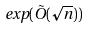Convert formula to latex. <formula><loc_0><loc_0><loc_500><loc_500>e x p ( \tilde { O } ( \sqrt { n } ) )</formula> 